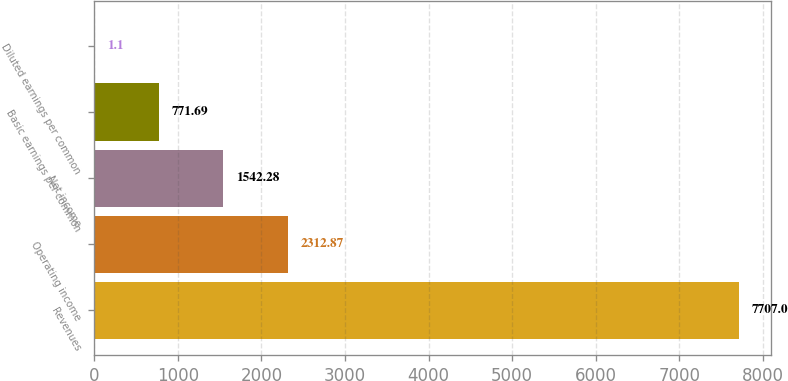<chart> <loc_0><loc_0><loc_500><loc_500><bar_chart><fcel>Revenues<fcel>Operating income<fcel>Net income<fcel>Basic earnings per common<fcel>Diluted earnings per common<nl><fcel>7707<fcel>2312.87<fcel>1542.28<fcel>771.69<fcel>1.1<nl></chart> 